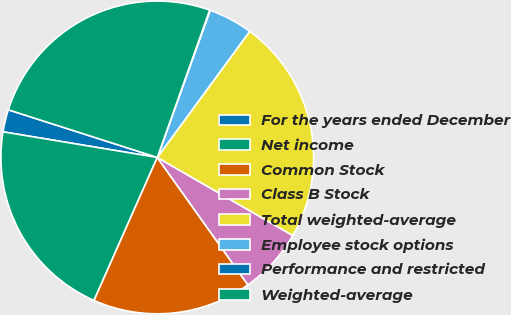Convert chart. <chart><loc_0><loc_0><loc_500><loc_500><pie_chart><fcel>For the years ended December<fcel>Net income<fcel>Common Stock<fcel>Class B Stock<fcel>Total weighted-average<fcel>Employee stock options<fcel>Performance and restricted<fcel>Weighted-average<nl><fcel>2.31%<fcel>20.99%<fcel>16.47%<fcel>6.84%<fcel>23.25%<fcel>4.58%<fcel>0.05%<fcel>25.51%<nl></chart> 